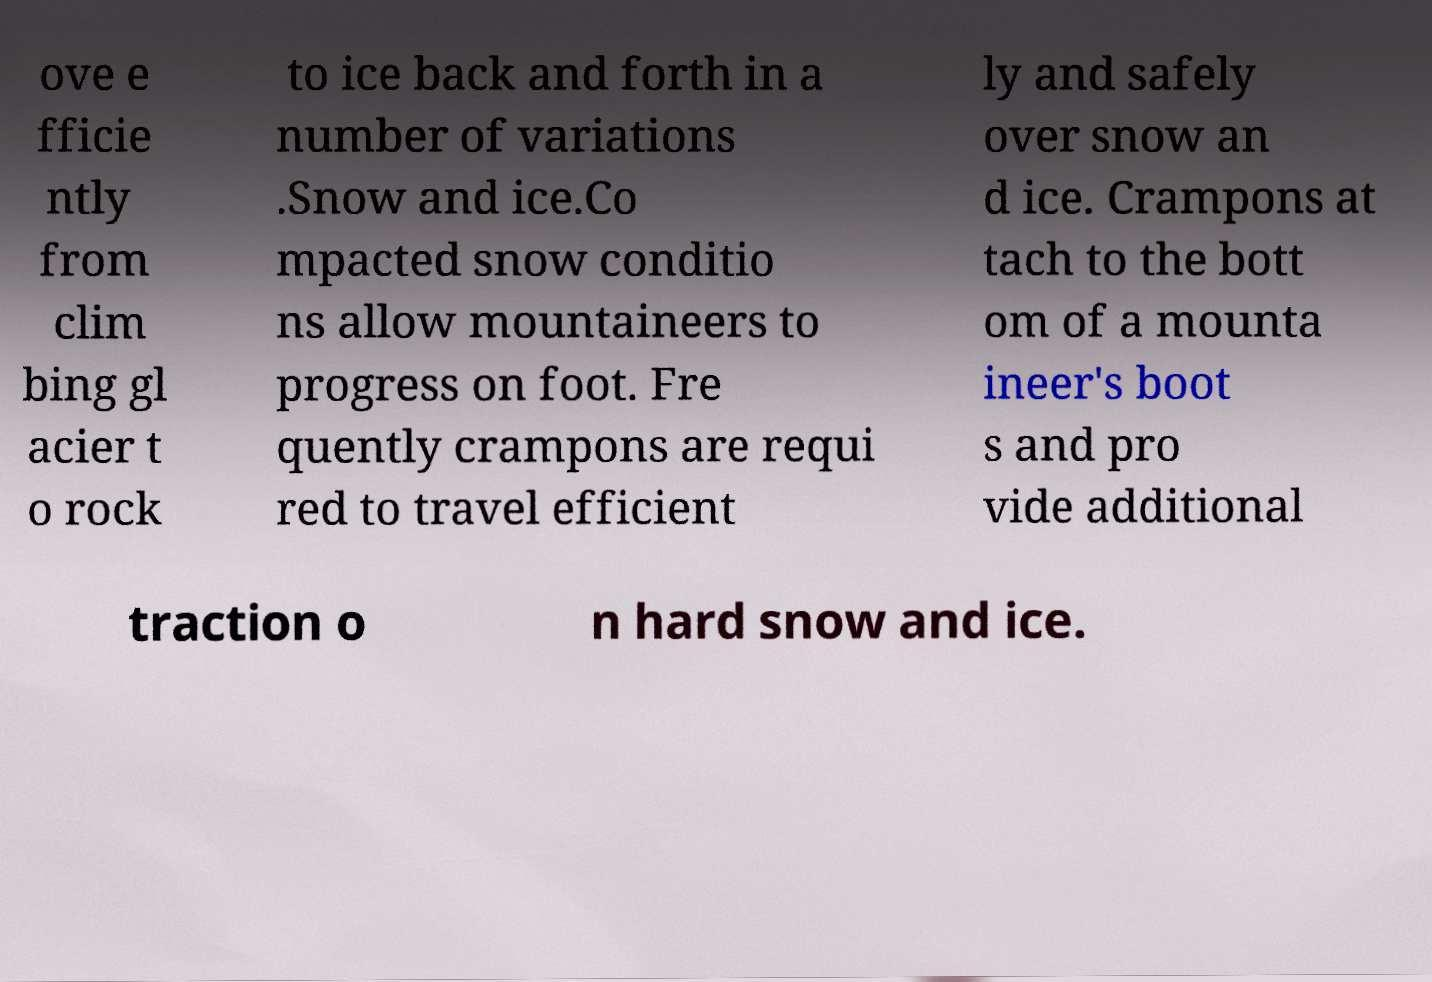Please read and relay the text visible in this image. What does it say? ove e fficie ntly from clim bing gl acier t o rock to ice back and forth in a number of variations .Snow and ice.Co mpacted snow conditio ns allow mountaineers to progress on foot. Fre quently crampons are requi red to travel efficient ly and safely over snow an d ice. Crampons at tach to the bott om of a mounta ineer's boot s and pro vide additional traction o n hard snow and ice. 